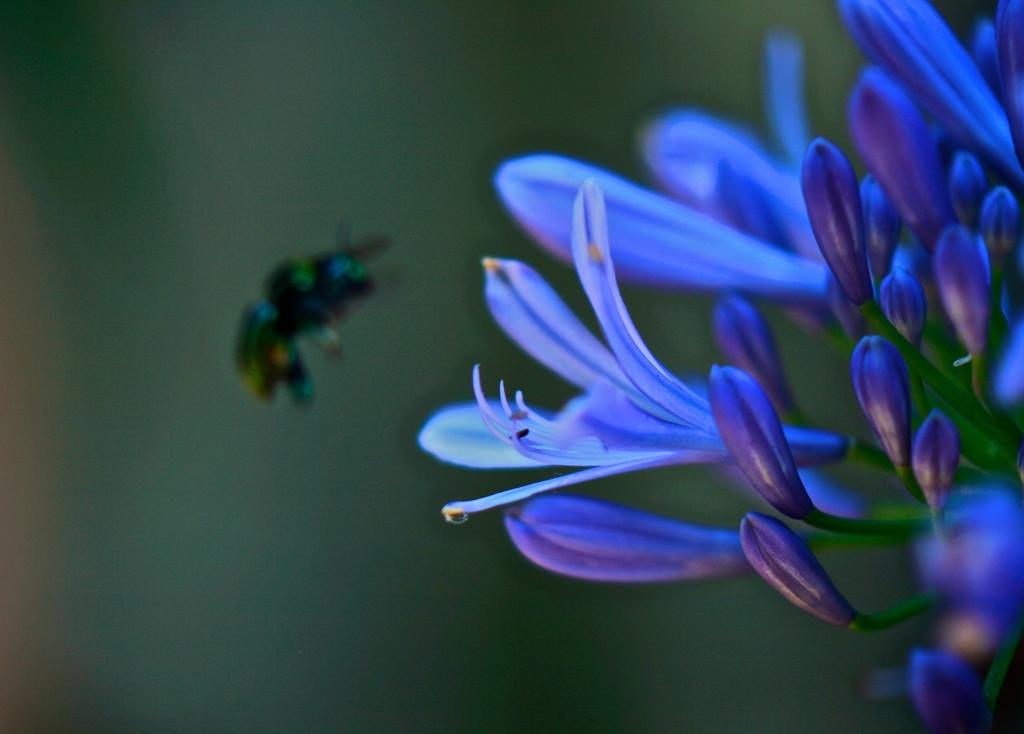What type of flora is present in the image? There are flowers in the image. What colors are the flowers? The flowers are blue and purple in color. What else can be seen in the image besides the flowers? There is an insect flying in the air in the image. How would you describe the background of the image? The background of the image is blurry. Is there a baby driving a car in the image? No, there is no baby or car present in the image. Can you see a cave in the background of the image? No, there is no cave visible in the image; the background is blurry and does not show any specific location or structure. 